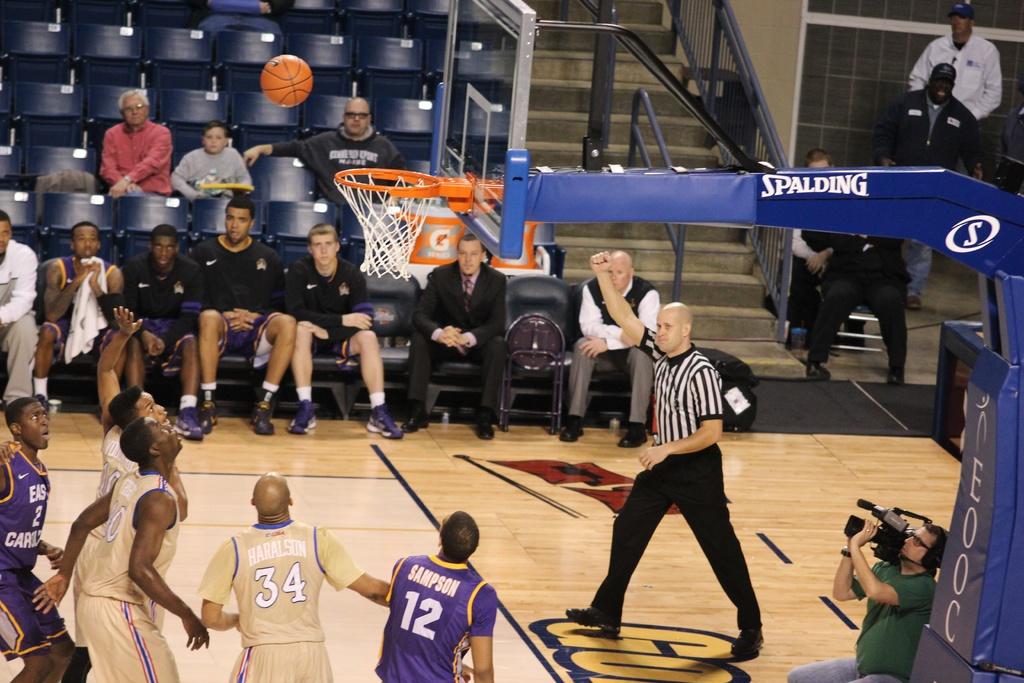Who makes the basketball goal?
Keep it short and to the point. Spalding. 